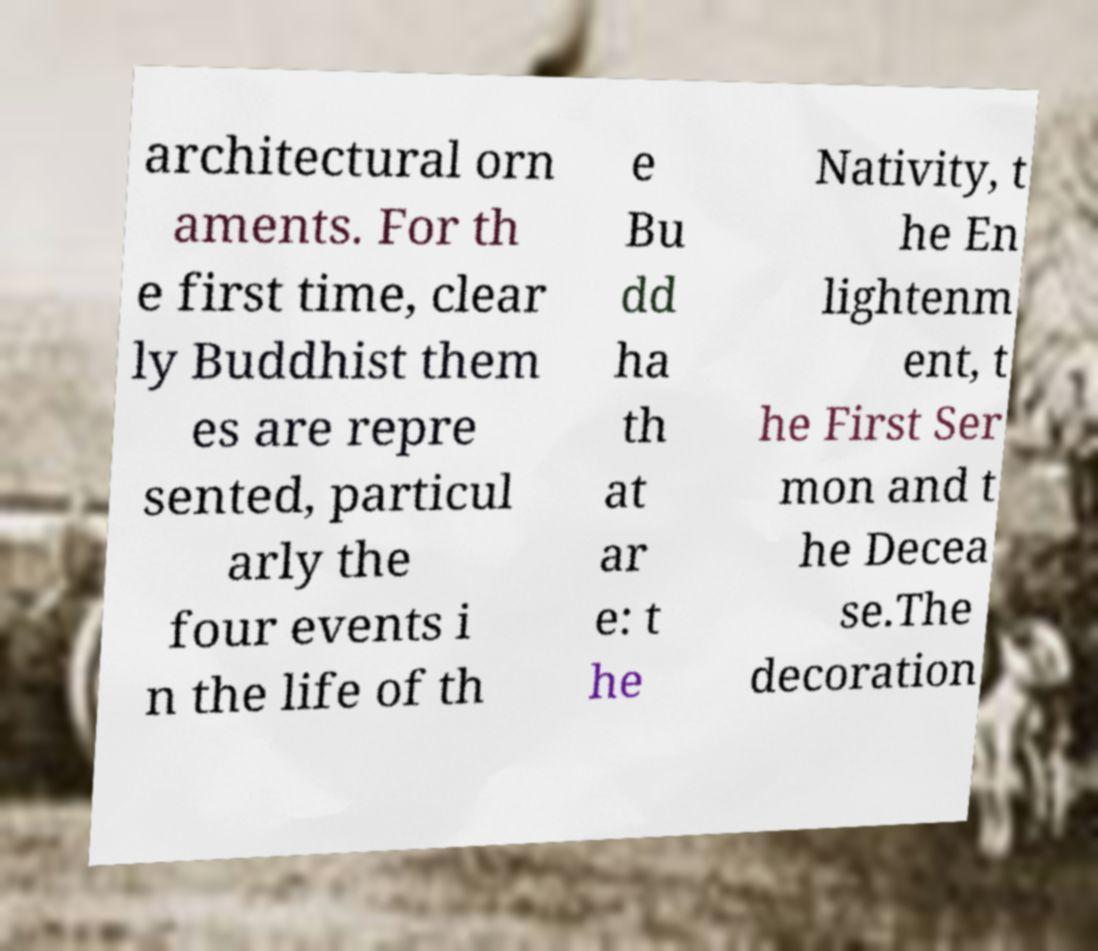Can you read and provide the text displayed in the image?This photo seems to have some interesting text. Can you extract and type it out for me? architectural orn aments. For th e first time, clear ly Buddhist them es are repre sented, particul arly the four events i n the life of th e Bu dd ha th at ar e: t he Nativity, t he En lightenm ent, t he First Ser mon and t he Decea se.The decoration 